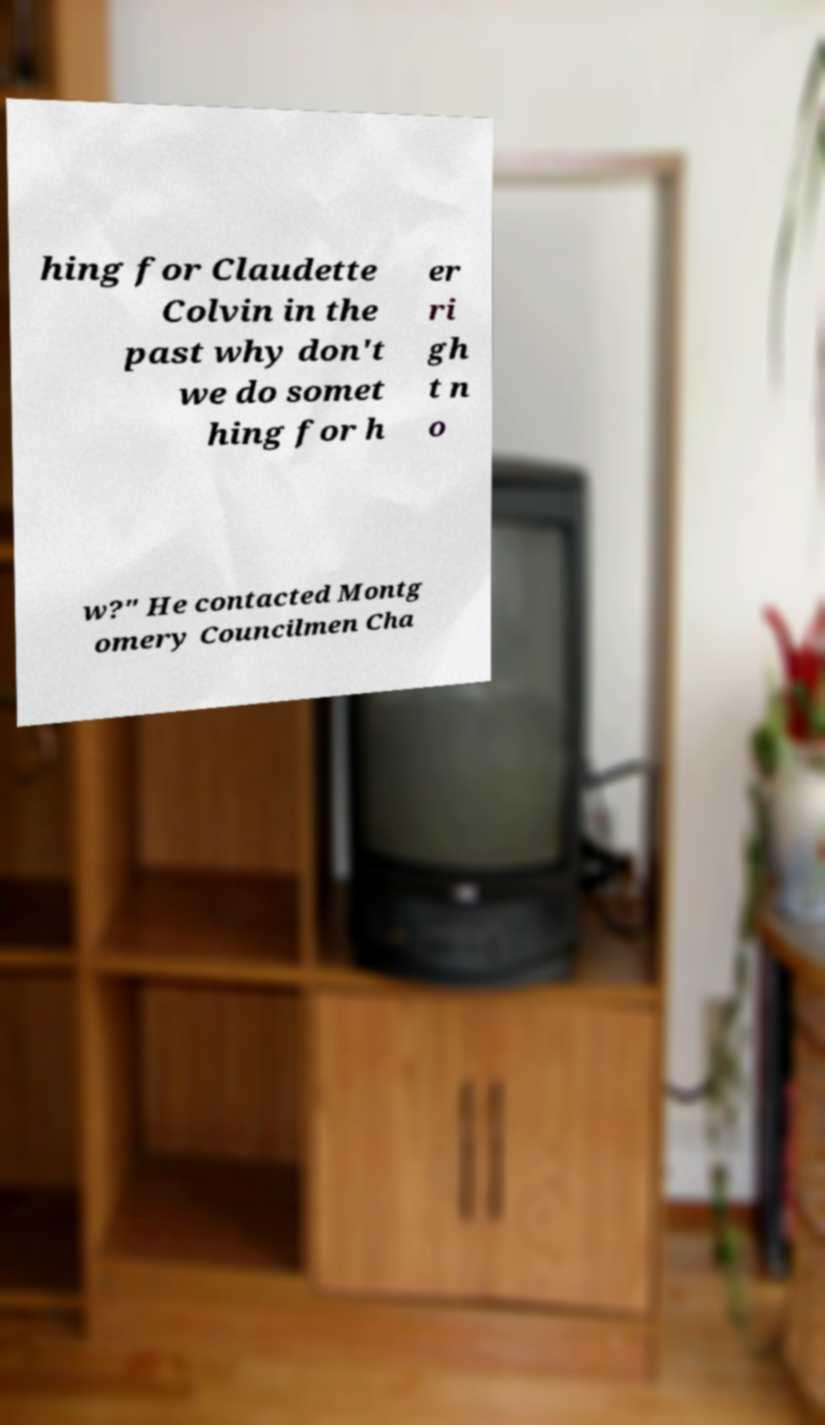I need the written content from this picture converted into text. Can you do that? hing for Claudette Colvin in the past why don't we do somet hing for h er ri gh t n o w?" He contacted Montg omery Councilmen Cha 